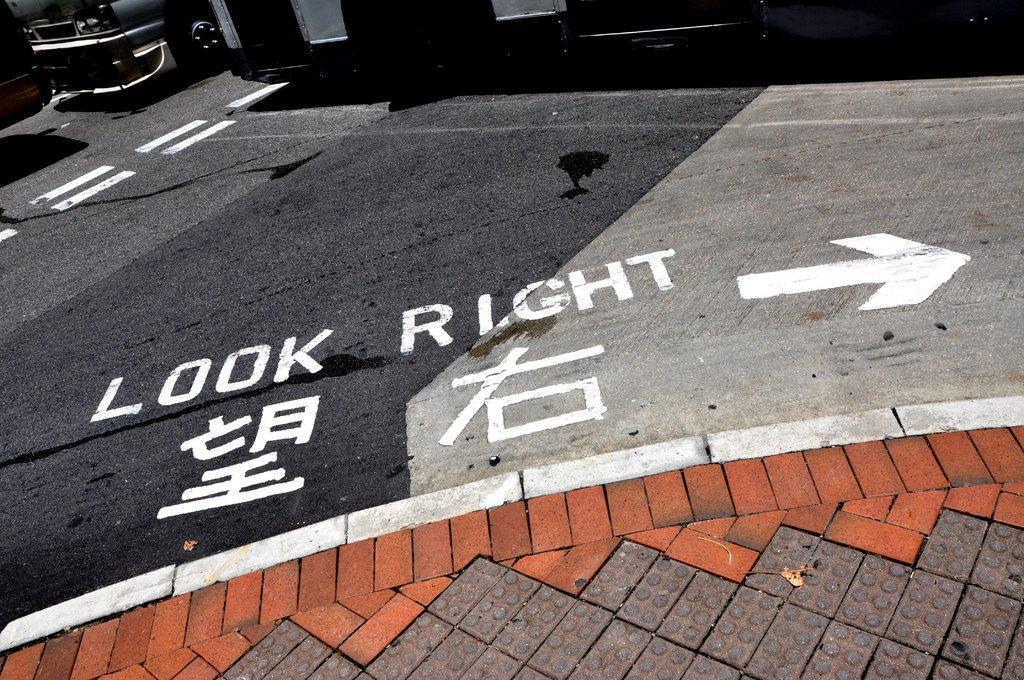Describe this image in one or two sentences. As we can see in the image there is a vehicle and building. The image is little dark. 